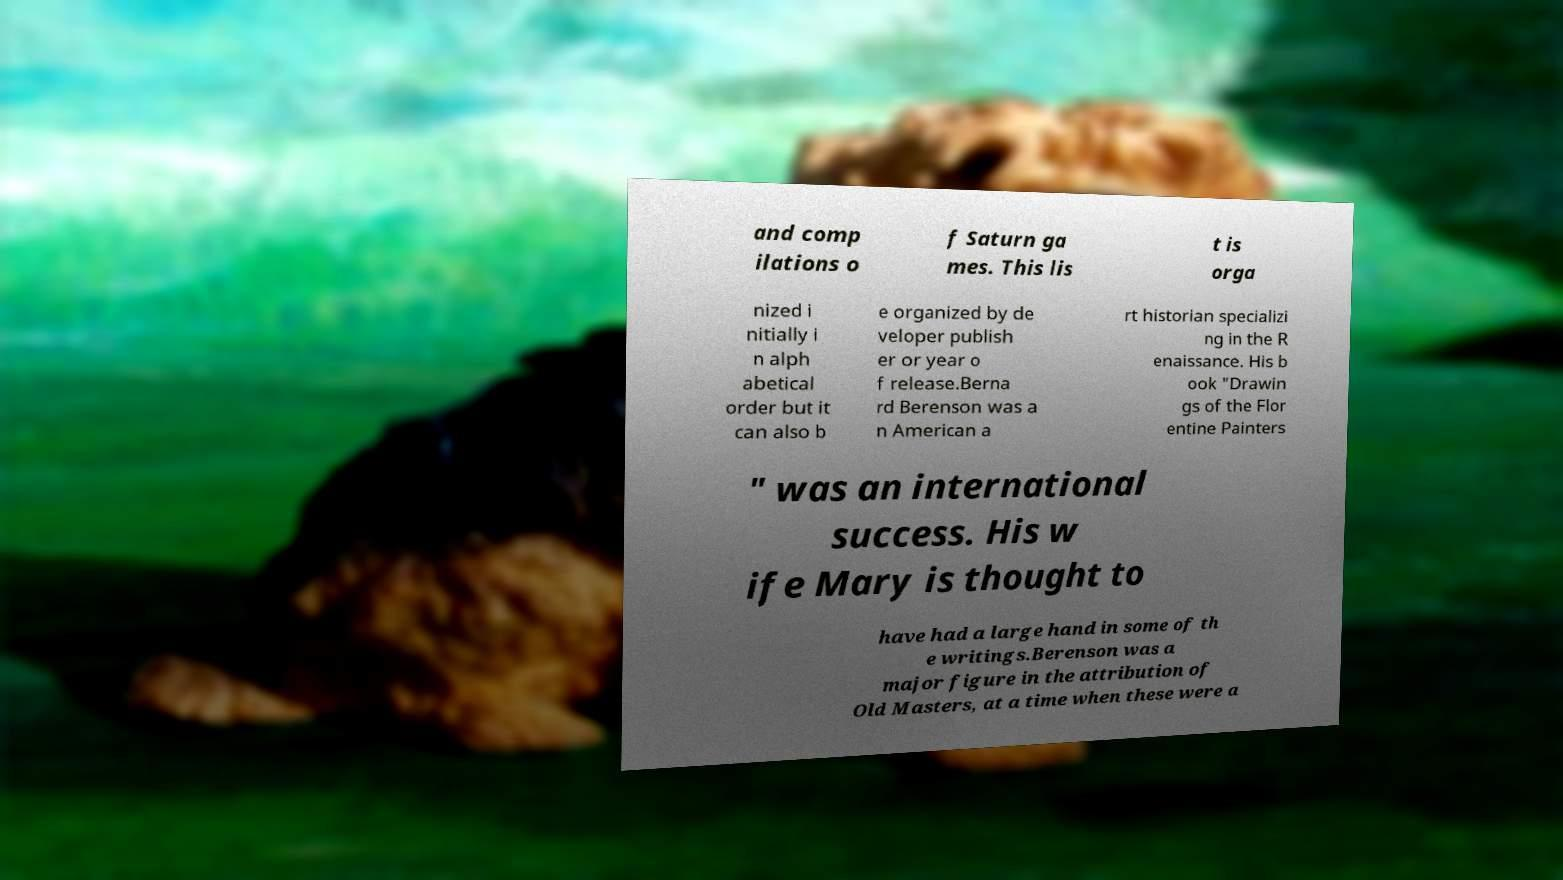Could you assist in decoding the text presented in this image and type it out clearly? and comp ilations o f Saturn ga mes. This lis t is orga nized i nitially i n alph abetical order but it can also b e organized by de veloper publish er or year o f release.Berna rd Berenson was a n American a rt historian specializi ng in the R enaissance. His b ook "Drawin gs of the Flor entine Painters " was an international success. His w ife Mary is thought to have had a large hand in some of th e writings.Berenson was a major figure in the attribution of Old Masters, at a time when these were a 